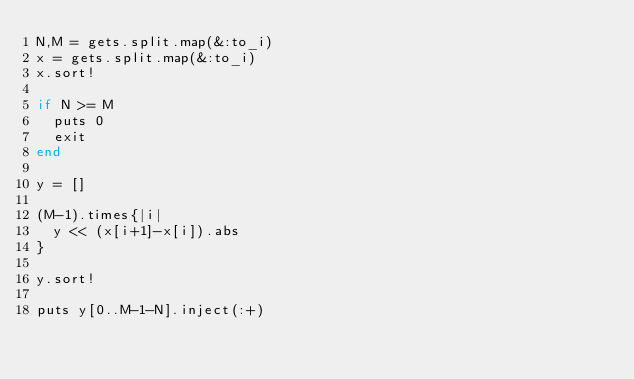<code> <loc_0><loc_0><loc_500><loc_500><_Ruby_>N,M = gets.split.map(&:to_i)
x = gets.split.map(&:to_i)
x.sort!

if N >= M
  puts 0
  exit
end

y = []

(M-1).times{|i|
  y << (x[i+1]-x[i]).abs
}

y.sort!

puts y[0..M-1-N].inject(:+)</code> 